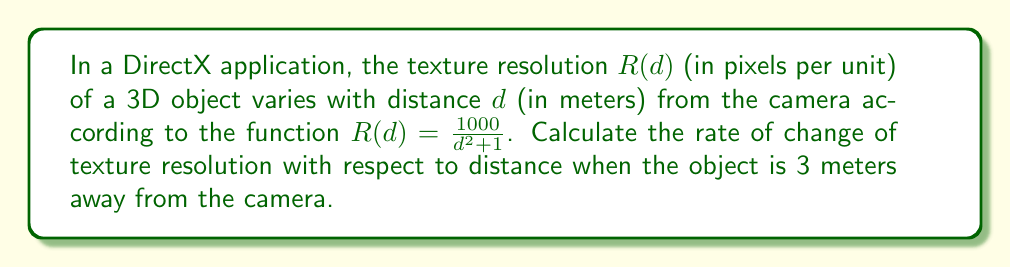Can you solve this math problem? To find the rate of change of texture resolution with respect to distance, we need to calculate the derivative of $R(d)$ and then evaluate it at $d = 3$.

Step 1: Express the function
$$R(d) = \frac{1000}{d^2 + 1}$$

Step 2: Calculate the derivative using the quotient rule
$$\frac{d}{dd}R(d) = \frac{d}{dd}\left(\frac{1000}{d^2 + 1}\right)$$
$$= \frac{0 \cdot (d^2 + 1) - 1000 \cdot \frac{d}{dd}(d^2 + 1)}{(d^2 + 1)^2}$$
$$= \frac{-1000 \cdot 2d}{(d^2 + 1)^2}$$
$$= -\frac{2000d}{(d^2 + 1)^2}$$

Step 3: Evaluate the derivative at $d = 3$
$$\left.\frac{d}{dd}R(d)\right|_{d=3} = -\frac{2000 \cdot 3}{(3^2 + 1)^2}$$
$$= -\frac{6000}{(9 + 1)^2}$$
$$= -\frac{6000}{100}$$
$$= -60$$

The negative sign indicates that the texture resolution decreases as the distance increases.
Answer: $-60$ pixels per unit per meter 